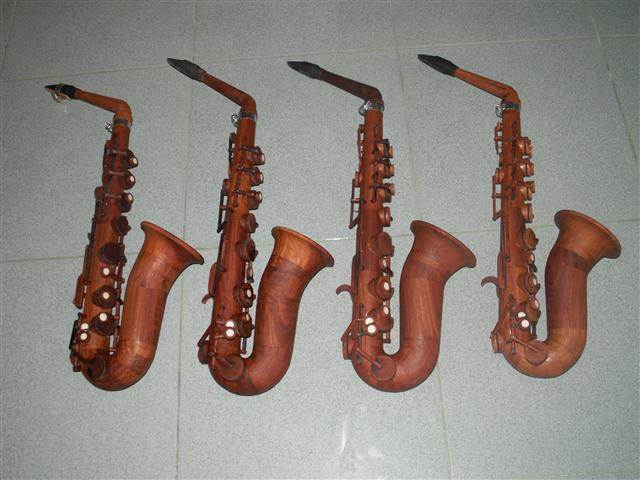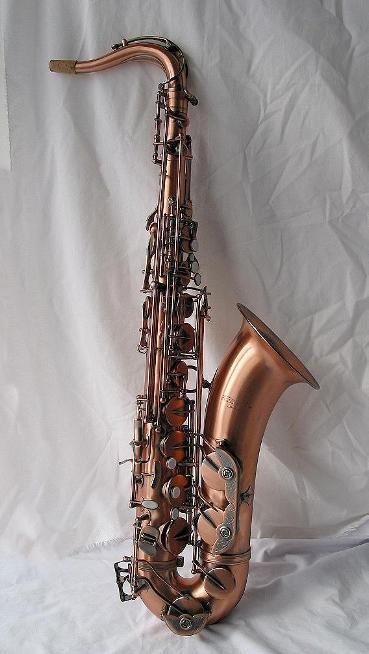The first image is the image on the left, the second image is the image on the right. For the images displayed, is the sentence "An image shows at least two wooden instruments displayed side-by-side." factually correct? Answer yes or no. Yes. The first image is the image on the left, the second image is the image on the right. Evaluate the accuracy of this statement regarding the images: "There are at least three saxophones.". Is it true? Answer yes or no. Yes. 